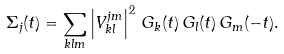Convert formula to latex. <formula><loc_0><loc_0><loc_500><loc_500>\Sigma _ { j } ( t ) = \sum _ { k l m } \left | V ^ { j m } _ { k l } \right | ^ { 2 } \, G _ { k } ( t ) \, G _ { l } ( t ) \, G _ { m } ( - t ) .</formula> 